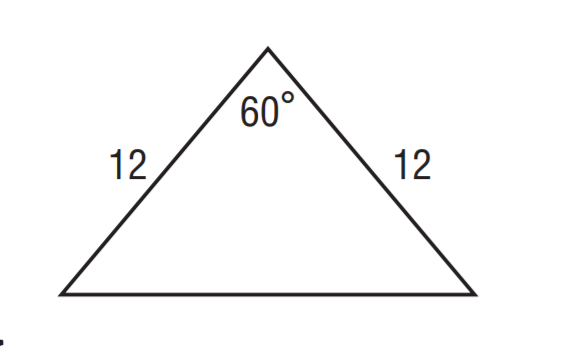Question: What is the perimeter of the triangle?
Choices:
A. 12
B. 24
C. 36
D. 104
Answer with the letter. Answer: C 